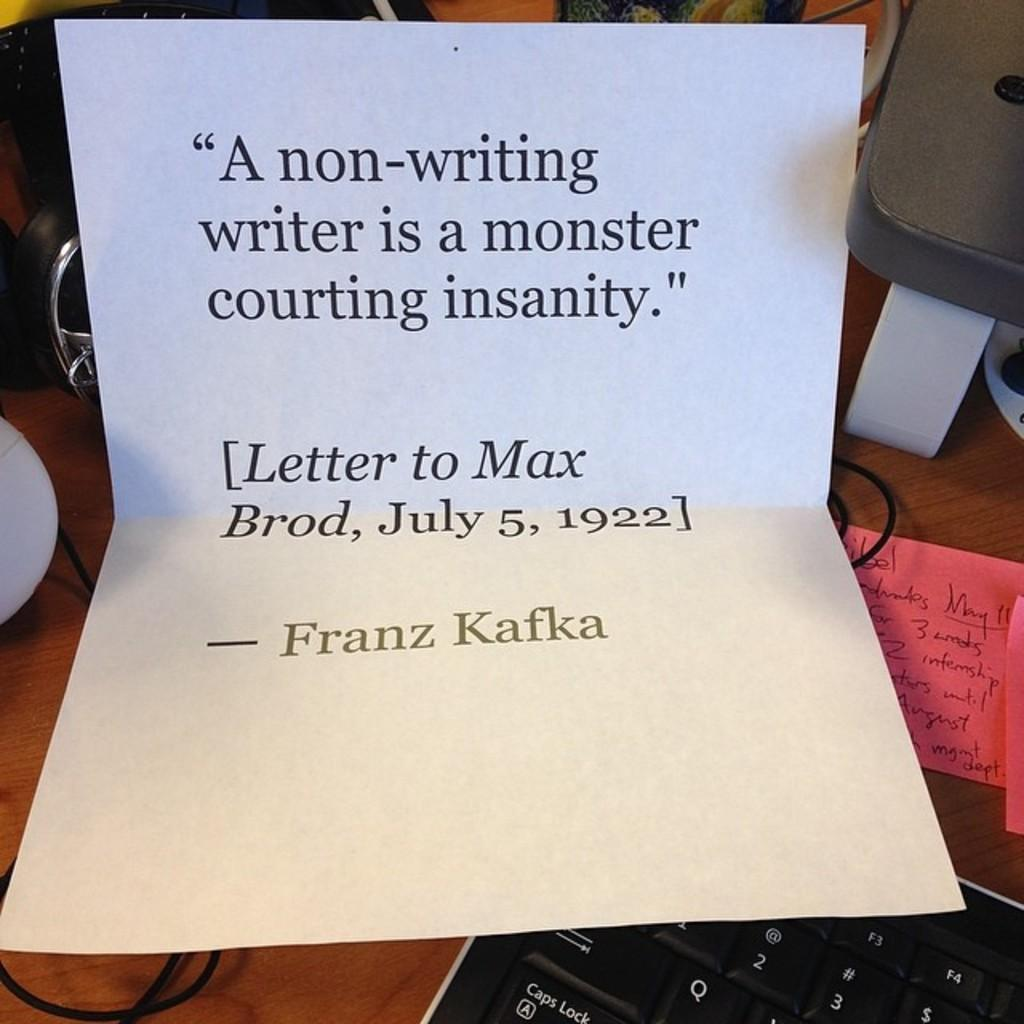What is written on the paper in the image? The provided facts do not specify the content of the text on the paper. What is the purpose of the keyboard in the image? The keyboard is likely used for typing or inputting data, but the specific purpose cannot be determined from the facts. What is displayed on the monitor in the image? The provided facts do not specify what is displayed on the monitor. What type of surface is the paper, keyboard, and monitor placed on? They are placed on a wooden table. What type of skirt is hanging on the bushes in the image? There are no bushes or skirts present in the image. How low is the monitor in the image? The provided facts do not mention the height or position of the monitor. 